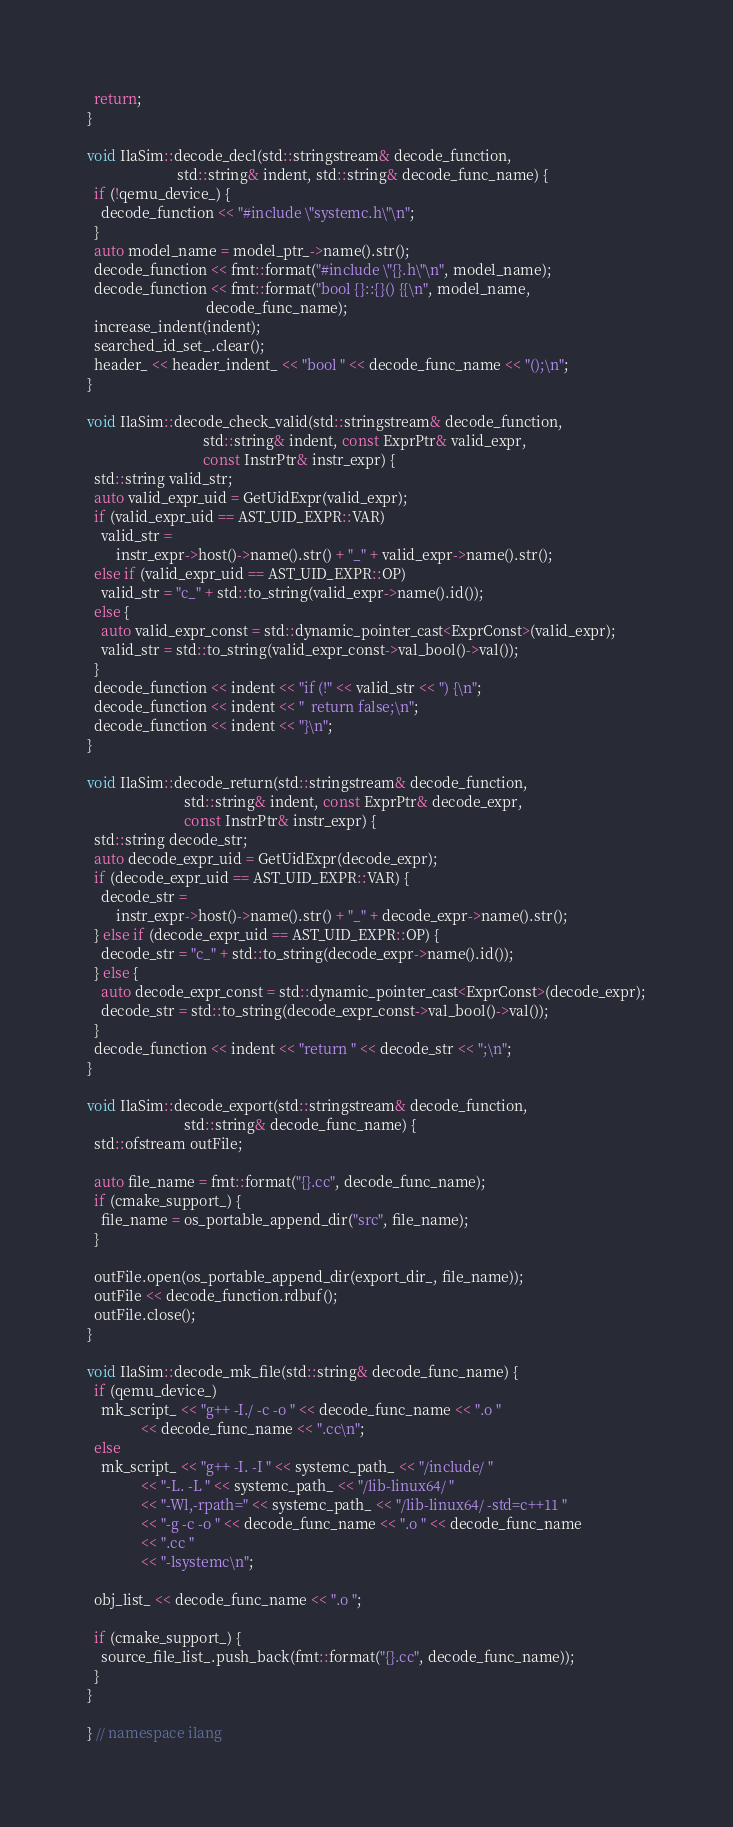<code> <loc_0><loc_0><loc_500><loc_500><_C++_>  return;
}

void IlaSim::decode_decl(std::stringstream& decode_function,
                         std::string& indent, std::string& decode_func_name) {
  if (!qemu_device_) {
    decode_function << "#include \"systemc.h\"\n";
  }
  auto model_name = model_ptr_->name().str();
  decode_function << fmt::format("#include \"{}.h\"\n", model_name);
  decode_function << fmt::format("bool {}::{}() {{\n", model_name,
                                 decode_func_name);
  increase_indent(indent);
  searched_id_set_.clear();
  header_ << header_indent_ << "bool " << decode_func_name << "();\n";
}

void IlaSim::decode_check_valid(std::stringstream& decode_function,
                                std::string& indent, const ExprPtr& valid_expr,
                                const InstrPtr& instr_expr) {
  std::string valid_str;
  auto valid_expr_uid = GetUidExpr(valid_expr);
  if (valid_expr_uid == AST_UID_EXPR::VAR)
    valid_str =
        instr_expr->host()->name().str() + "_" + valid_expr->name().str();
  else if (valid_expr_uid == AST_UID_EXPR::OP)
    valid_str = "c_" + std::to_string(valid_expr->name().id());
  else {
    auto valid_expr_const = std::dynamic_pointer_cast<ExprConst>(valid_expr);
    valid_str = std::to_string(valid_expr_const->val_bool()->val());
  }
  decode_function << indent << "if (!" << valid_str << ") {\n";
  decode_function << indent << "  return false;\n";
  decode_function << indent << "}\n";
}

void IlaSim::decode_return(std::stringstream& decode_function,
                           std::string& indent, const ExprPtr& decode_expr,
                           const InstrPtr& instr_expr) {
  std::string decode_str;
  auto decode_expr_uid = GetUidExpr(decode_expr);
  if (decode_expr_uid == AST_UID_EXPR::VAR) {
    decode_str =
        instr_expr->host()->name().str() + "_" + decode_expr->name().str();
  } else if (decode_expr_uid == AST_UID_EXPR::OP) {
    decode_str = "c_" + std::to_string(decode_expr->name().id());
  } else {
    auto decode_expr_const = std::dynamic_pointer_cast<ExprConst>(decode_expr);
    decode_str = std::to_string(decode_expr_const->val_bool()->val());
  }
  decode_function << indent << "return " << decode_str << ";\n";
}

void IlaSim::decode_export(std::stringstream& decode_function,
                           std::string& decode_func_name) {
  std::ofstream outFile;

  auto file_name = fmt::format("{}.cc", decode_func_name);
  if (cmake_support_) {
    file_name = os_portable_append_dir("src", file_name);
  }

  outFile.open(os_portable_append_dir(export_dir_, file_name));
  outFile << decode_function.rdbuf();
  outFile.close();
}

void IlaSim::decode_mk_file(std::string& decode_func_name) {
  if (qemu_device_)
    mk_script_ << "g++ -I./ -c -o " << decode_func_name << ".o "
               << decode_func_name << ".cc\n";
  else
    mk_script_ << "g++ -I. -I " << systemc_path_ << "/include/ "
               << "-L. -L " << systemc_path_ << "/lib-linux64/ "
               << "-Wl,-rpath=" << systemc_path_ << "/lib-linux64/ -std=c++11 "
               << "-g -c -o " << decode_func_name << ".o " << decode_func_name
               << ".cc "
               << "-lsystemc\n";

  obj_list_ << decode_func_name << ".o ";

  if (cmake_support_) {
    source_file_list_.push_back(fmt::format("{}.cc", decode_func_name));
  }
}

} // namespace ilang
</code> 